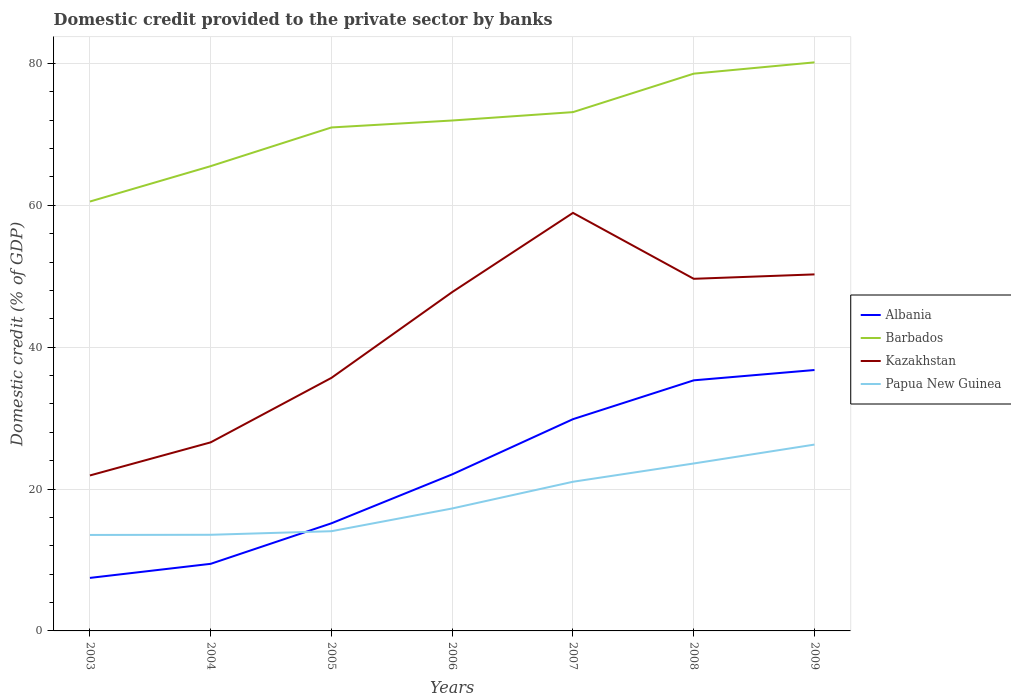Does the line corresponding to Kazakhstan intersect with the line corresponding to Albania?
Give a very brief answer. No. Is the number of lines equal to the number of legend labels?
Keep it short and to the point. Yes. Across all years, what is the maximum domestic credit provided to the private sector by banks in Kazakhstan?
Your answer should be compact. 21.92. What is the total domestic credit provided to the private sector by banks in Barbados in the graph?
Provide a succinct answer. -1.18. What is the difference between the highest and the second highest domestic credit provided to the private sector by banks in Albania?
Provide a succinct answer. 29.31. What is the difference between the highest and the lowest domestic credit provided to the private sector by banks in Barbados?
Offer a very short reply. 4. What is the difference between two consecutive major ticks on the Y-axis?
Give a very brief answer. 20. Are the values on the major ticks of Y-axis written in scientific E-notation?
Make the answer very short. No. Does the graph contain grids?
Your answer should be very brief. Yes. Where does the legend appear in the graph?
Your answer should be very brief. Center right. How many legend labels are there?
Your answer should be compact. 4. How are the legend labels stacked?
Give a very brief answer. Vertical. What is the title of the graph?
Your answer should be compact. Domestic credit provided to the private sector by banks. Does "Sao Tome and Principe" appear as one of the legend labels in the graph?
Your answer should be very brief. No. What is the label or title of the Y-axis?
Give a very brief answer. Domestic credit (% of GDP). What is the Domestic credit (% of GDP) of Albania in 2003?
Provide a short and direct response. 7.48. What is the Domestic credit (% of GDP) in Barbados in 2003?
Make the answer very short. 60.54. What is the Domestic credit (% of GDP) of Kazakhstan in 2003?
Offer a very short reply. 21.92. What is the Domestic credit (% of GDP) in Papua New Guinea in 2003?
Keep it short and to the point. 13.53. What is the Domestic credit (% of GDP) in Albania in 2004?
Make the answer very short. 9.46. What is the Domestic credit (% of GDP) in Barbados in 2004?
Ensure brevity in your answer.  65.53. What is the Domestic credit (% of GDP) in Kazakhstan in 2004?
Offer a terse response. 26.59. What is the Domestic credit (% of GDP) in Papua New Guinea in 2004?
Keep it short and to the point. 13.56. What is the Domestic credit (% of GDP) in Albania in 2005?
Provide a short and direct response. 15.18. What is the Domestic credit (% of GDP) in Barbados in 2005?
Offer a very short reply. 70.98. What is the Domestic credit (% of GDP) of Kazakhstan in 2005?
Offer a terse response. 35.68. What is the Domestic credit (% of GDP) in Papua New Guinea in 2005?
Provide a short and direct response. 14.06. What is the Domestic credit (% of GDP) in Albania in 2006?
Your response must be concise. 22.07. What is the Domestic credit (% of GDP) in Barbados in 2006?
Offer a terse response. 71.96. What is the Domestic credit (% of GDP) in Kazakhstan in 2006?
Provide a short and direct response. 47.77. What is the Domestic credit (% of GDP) in Papua New Guinea in 2006?
Give a very brief answer. 17.27. What is the Domestic credit (% of GDP) in Albania in 2007?
Offer a very short reply. 29.86. What is the Domestic credit (% of GDP) of Barbados in 2007?
Keep it short and to the point. 73.15. What is the Domestic credit (% of GDP) in Kazakhstan in 2007?
Ensure brevity in your answer.  58.94. What is the Domestic credit (% of GDP) in Papua New Guinea in 2007?
Ensure brevity in your answer.  21.03. What is the Domestic credit (% of GDP) in Albania in 2008?
Give a very brief answer. 35.33. What is the Domestic credit (% of GDP) of Barbados in 2008?
Offer a terse response. 78.57. What is the Domestic credit (% of GDP) of Kazakhstan in 2008?
Your answer should be compact. 49.64. What is the Domestic credit (% of GDP) of Papua New Guinea in 2008?
Your response must be concise. 23.61. What is the Domestic credit (% of GDP) in Albania in 2009?
Offer a very short reply. 36.78. What is the Domestic credit (% of GDP) in Barbados in 2009?
Your response must be concise. 80.16. What is the Domestic credit (% of GDP) in Kazakhstan in 2009?
Give a very brief answer. 50.27. What is the Domestic credit (% of GDP) of Papua New Guinea in 2009?
Your response must be concise. 26.27. Across all years, what is the maximum Domestic credit (% of GDP) of Albania?
Offer a terse response. 36.78. Across all years, what is the maximum Domestic credit (% of GDP) in Barbados?
Provide a short and direct response. 80.16. Across all years, what is the maximum Domestic credit (% of GDP) of Kazakhstan?
Offer a terse response. 58.94. Across all years, what is the maximum Domestic credit (% of GDP) of Papua New Guinea?
Provide a succinct answer. 26.27. Across all years, what is the minimum Domestic credit (% of GDP) of Albania?
Make the answer very short. 7.48. Across all years, what is the minimum Domestic credit (% of GDP) of Barbados?
Ensure brevity in your answer.  60.54. Across all years, what is the minimum Domestic credit (% of GDP) in Kazakhstan?
Ensure brevity in your answer.  21.92. Across all years, what is the minimum Domestic credit (% of GDP) of Papua New Guinea?
Ensure brevity in your answer.  13.53. What is the total Domestic credit (% of GDP) in Albania in the graph?
Your response must be concise. 156.16. What is the total Domestic credit (% of GDP) of Barbados in the graph?
Keep it short and to the point. 500.89. What is the total Domestic credit (% of GDP) in Kazakhstan in the graph?
Your answer should be very brief. 290.81. What is the total Domestic credit (% of GDP) of Papua New Guinea in the graph?
Make the answer very short. 129.32. What is the difference between the Domestic credit (% of GDP) in Albania in 2003 and that in 2004?
Give a very brief answer. -1.99. What is the difference between the Domestic credit (% of GDP) in Barbados in 2003 and that in 2004?
Give a very brief answer. -4.99. What is the difference between the Domestic credit (% of GDP) of Kazakhstan in 2003 and that in 2004?
Your response must be concise. -4.67. What is the difference between the Domestic credit (% of GDP) in Papua New Guinea in 2003 and that in 2004?
Your response must be concise. -0.03. What is the difference between the Domestic credit (% of GDP) in Albania in 2003 and that in 2005?
Keep it short and to the point. -7.7. What is the difference between the Domestic credit (% of GDP) of Barbados in 2003 and that in 2005?
Make the answer very short. -10.44. What is the difference between the Domestic credit (% of GDP) in Kazakhstan in 2003 and that in 2005?
Your answer should be compact. -13.76. What is the difference between the Domestic credit (% of GDP) of Papua New Guinea in 2003 and that in 2005?
Provide a succinct answer. -0.53. What is the difference between the Domestic credit (% of GDP) of Albania in 2003 and that in 2006?
Your answer should be compact. -14.6. What is the difference between the Domestic credit (% of GDP) of Barbados in 2003 and that in 2006?
Offer a terse response. -11.42. What is the difference between the Domestic credit (% of GDP) in Kazakhstan in 2003 and that in 2006?
Your answer should be compact. -25.85. What is the difference between the Domestic credit (% of GDP) of Papua New Guinea in 2003 and that in 2006?
Keep it short and to the point. -3.74. What is the difference between the Domestic credit (% of GDP) in Albania in 2003 and that in 2007?
Provide a succinct answer. -22.38. What is the difference between the Domestic credit (% of GDP) in Barbados in 2003 and that in 2007?
Offer a very short reply. -12.61. What is the difference between the Domestic credit (% of GDP) of Kazakhstan in 2003 and that in 2007?
Keep it short and to the point. -37.02. What is the difference between the Domestic credit (% of GDP) of Papua New Guinea in 2003 and that in 2007?
Provide a succinct answer. -7.5. What is the difference between the Domestic credit (% of GDP) of Albania in 2003 and that in 2008?
Your answer should be very brief. -27.86. What is the difference between the Domestic credit (% of GDP) in Barbados in 2003 and that in 2008?
Your answer should be very brief. -18.03. What is the difference between the Domestic credit (% of GDP) in Kazakhstan in 2003 and that in 2008?
Offer a very short reply. -27.73. What is the difference between the Domestic credit (% of GDP) of Papua New Guinea in 2003 and that in 2008?
Offer a very short reply. -10.08. What is the difference between the Domestic credit (% of GDP) of Albania in 2003 and that in 2009?
Your answer should be compact. -29.31. What is the difference between the Domestic credit (% of GDP) of Barbados in 2003 and that in 2009?
Provide a short and direct response. -19.62. What is the difference between the Domestic credit (% of GDP) in Kazakhstan in 2003 and that in 2009?
Give a very brief answer. -28.35. What is the difference between the Domestic credit (% of GDP) of Papua New Guinea in 2003 and that in 2009?
Provide a succinct answer. -12.74. What is the difference between the Domestic credit (% of GDP) in Albania in 2004 and that in 2005?
Give a very brief answer. -5.71. What is the difference between the Domestic credit (% of GDP) of Barbados in 2004 and that in 2005?
Your answer should be compact. -5.46. What is the difference between the Domestic credit (% of GDP) of Kazakhstan in 2004 and that in 2005?
Provide a succinct answer. -9.09. What is the difference between the Domestic credit (% of GDP) of Papua New Guinea in 2004 and that in 2005?
Your answer should be very brief. -0.5. What is the difference between the Domestic credit (% of GDP) in Albania in 2004 and that in 2006?
Your response must be concise. -12.61. What is the difference between the Domestic credit (% of GDP) of Barbados in 2004 and that in 2006?
Your answer should be compact. -6.44. What is the difference between the Domestic credit (% of GDP) in Kazakhstan in 2004 and that in 2006?
Make the answer very short. -21.19. What is the difference between the Domestic credit (% of GDP) of Papua New Guinea in 2004 and that in 2006?
Your answer should be compact. -3.71. What is the difference between the Domestic credit (% of GDP) of Albania in 2004 and that in 2007?
Offer a terse response. -20.39. What is the difference between the Domestic credit (% of GDP) of Barbados in 2004 and that in 2007?
Give a very brief answer. -7.62. What is the difference between the Domestic credit (% of GDP) in Kazakhstan in 2004 and that in 2007?
Your answer should be compact. -32.35. What is the difference between the Domestic credit (% of GDP) in Papua New Guinea in 2004 and that in 2007?
Your answer should be very brief. -7.48. What is the difference between the Domestic credit (% of GDP) in Albania in 2004 and that in 2008?
Give a very brief answer. -25.87. What is the difference between the Domestic credit (% of GDP) in Barbados in 2004 and that in 2008?
Your answer should be compact. -13.04. What is the difference between the Domestic credit (% of GDP) in Kazakhstan in 2004 and that in 2008?
Keep it short and to the point. -23.06. What is the difference between the Domestic credit (% of GDP) in Papua New Guinea in 2004 and that in 2008?
Your answer should be compact. -10.05. What is the difference between the Domestic credit (% of GDP) in Albania in 2004 and that in 2009?
Give a very brief answer. -27.32. What is the difference between the Domestic credit (% of GDP) of Barbados in 2004 and that in 2009?
Offer a very short reply. -14.63. What is the difference between the Domestic credit (% of GDP) in Kazakhstan in 2004 and that in 2009?
Offer a terse response. -23.68. What is the difference between the Domestic credit (% of GDP) of Papua New Guinea in 2004 and that in 2009?
Your answer should be compact. -12.72. What is the difference between the Domestic credit (% of GDP) in Albania in 2005 and that in 2006?
Your answer should be very brief. -6.9. What is the difference between the Domestic credit (% of GDP) of Barbados in 2005 and that in 2006?
Your response must be concise. -0.98. What is the difference between the Domestic credit (% of GDP) of Kazakhstan in 2005 and that in 2006?
Give a very brief answer. -12.09. What is the difference between the Domestic credit (% of GDP) of Papua New Guinea in 2005 and that in 2006?
Make the answer very short. -3.21. What is the difference between the Domestic credit (% of GDP) of Albania in 2005 and that in 2007?
Your answer should be very brief. -14.68. What is the difference between the Domestic credit (% of GDP) in Barbados in 2005 and that in 2007?
Your answer should be very brief. -2.16. What is the difference between the Domestic credit (% of GDP) of Kazakhstan in 2005 and that in 2007?
Provide a succinct answer. -23.26. What is the difference between the Domestic credit (% of GDP) in Papua New Guinea in 2005 and that in 2007?
Your answer should be compact. -6.97. What is the difference between the Domestic credit (% of GDP) of Albania in 2005 and that in 2008?
Provide a succinct answer. -20.16. What is the difference between the Domestic credit (% of GDP) of Barbados in 2005 and that in 2008?
Offer a terse response. -7.58. What is the difference between the Domestic credit (% of GDP) of Kazakhstan in 2005 and that in 2008?
Your answer should be very brief. -13.97. What is the difference between the Domestic credit (% of GDP) of Papua New Guinea in 2005 and that in 2008?
Your response must be concise. -9.55. What is the difference between the Domestic credit (% of GDP) of Albania in 2005 and that in 2009?
Make the answer very short. -21.61. What is the difference between the Domestic credit (% of GDP) of Barbados in 2005 and that in 2009?
Provide a short and direct response. -9.18. What is the difference between the Domestic credit (% of GDP) in Kazakhstan in 2005 and that in 2009?
Your response must be concise. -14.59. What is the difference between the Domestic credit (% of GDP) of Papua New Guinea in 2005 and that in 2009?
Ensure brevity in your answer.  -12.21. What is the difference between the Domestic credit (% of GDP) of Albania in 2006 and that in 2007?
Keep it short and to the point. -7.78. What is the difference between the Domestic credit (% of GDP) in Barbados in 2006 and that in 2007?
Your answer should be very brief. -1.18. What is the difference between the Domestic credit (% of GDP) in Kazakhstan in 2006 and that in 2007?
Provide a short and direct response. -11.16. What is the difference between the Domestic credit (% of GDP) in Papua New Guinea in 2006 and that in 2007?
Keep it short and to the point. -3.77. What is the difference between the Domestic credit (% of GDP) in Albania in 2006 and that in 2008?
Provide a short and direct response. -13.26. What is the difference between the Domestic credit (% of GDP) of Barbados in 2006 and that in 2008?
Give a very brief answer. -6.6. What is the difference between the Domestic credit (% of GDP) in Kazakhstan in 2006 and that in 2008?
Offer a very short reply. -1.87. What is the difference between the Domestic credit (% of GDP) in Papua New Guinea in 2006 and that in 2008?
Your answer should be very brief. -6.34. What is the difference between the Domestic credit (% of GDP) of Albania in 2006 and that in 2009?
Offer a terse response. -14.71. What is the difference between the Domestic credit (% of GDP) in Barbados in 2006 and that in 2009?
Your answer should be very brief. -8.2. What is the difference between the Domestic credit (% of GDP) of Kazakhstan in 2006 and that in 2009?
Offer a very short reply. -2.49. What is the difference between the Domestic credit (% of GDP) of Papua New Guinea in 2006 and that in 2009?
Give a very brief answer. -9.01. What is the difference between the Domestic credit (% of GDP) of Albania in 2007 and that in 2008?
Your answer should be very brief. -5.48. What is the difference between the Domestic credit (% of GDP) in Barbados in 2007 and that in 2008?
Your answer should be compact. -5.42. What is the difference between the Domestic credit (% of GDP) of Kazakhstan in 2007 and that in 2008?
Make the answer very short. 9.29. What is the difference between the Domestic credit (% of GDP) in Papua New Guinea in 2007 and that in 2008?
Keep it short and to the point. -2.58. What is the difference between the Domestic credit (% of GDP) of Albania in 2007 and that in 2009?
Give a very brief answer. -6.93. What is the difference between the Domestic credit (% of GDP) of Barbados in 2007 and that in 2009?
Make the answer very short. -7.02. What is the difference between the Domestic credit (% of GDP) of Kazakhstan in 2007 and that in 2009?
Give a very brief answer. 8.67. What is the difference between the Domestic credit (% of GDP) in Papua New Guinea in 2007 and that in 2009?
Keep it short and to the point. -5.24. What is the difference between the Domestic credit (% of GDP) in Albania in 2008 and that in 2009?
Your answer should be very brief. -1.45. What is the difference between the Domestic credit (% of GDP) of Barbados in 2008 and that in 2009?
Your answer should be very brief. -1.59. What is the difference between the Domestic credit (% of GDP) of Kazakhstan in 2008 and that in 2009?
Make the answer very short. -0.62. What is the difference between the Domestic credit (% of GDP) in Papua New Guinea in 2008 and that in 2009?
Your response must be concise. -2.66. What is the difference between the Domestic credit (% of GDP) in Albania in 2003 and the Domestic credit (% of GDP) in Barbados in 2004?
Offer a terse response. -58.05. What is the difference between the Domestic credit (% of GDP) of Albania in 2003 and the Domestic credit (% of GDP) of Kazakhstan in 2004?
Offer a terse response. -19.11. What is the difference between the Domestic credit (% of GDP) in Albania in 2003 and the Domestic credit (% of GDP) in Papua New Guinea in 2004?
Your answer should be very brief. -6.08. What is the difference between the Domestic credit (% of GDP) in Barbados in 2003 and the Domestic credit (% of GDP) in Kazakhstan in 2004?
Make the answer very short. 33.95. What is the difference between the Domestic credit (% of GDP) in Barbados in 2003 and the Domestic credit (% of GDP) in Papua New Guinea in 2004?
Ensure brevity in your answer.  46.98. What is the difference between the Domestic credit (% of GDP) of Kazakhstan in 2003 and the Domestic credit (% of GDP) of Papua New Guinea in 2004?
Your answer should be very brief. 8.36. What is the difference between the Domestic credit (% of GDP) in Albania in 2003 and the Domestic credit (% of GDP) in Barbados in 2005?
Your answer should be very brief. -63.51. What is the difference between the Domestic credit (% of GDP) in Albania in 2003 and the Domestic credit (% of GDP) in Kazakhstan in 2005?
Give a very brief answer. -28.2. What is the difference between the Domestic credit (% of GDP) in Albania in 2003 and the Domestic credit (% of GDP) in Papua New Guinea in 2005?
Ensure brevity in your answer.  -6.58. What is the difference between the Domestic credit (% of GDP) of Barbados in 2003 and the Domestic credit (% of GDP) of Kazakhstan in 2005?
Your answer should be very brief. 24.86. What is the difference between the Domestic credit (% of GDP) of Barbados in 2003 and the Domestic credit (% of GDP) of Papua New Guinea in 2005?
Provide a short and direct response. 46.48. What is the difference between the Domestic credit (% of GDP) of Kazakhstan in 2003 and the Domestic credit (% of GDP) of Papua New Guinea in 2005?
Keep it short and to the point. 7.86. What is the difference between the Domestic credit (% of GDP) of Albania in 2003 and the Domestic credit (% of GDP) of Barbados in 2006?
Give a very brief answer. -64.49. What is the difference between the Domestic credit (% of GDP) in Albania in 2003 and the Domestic credit (% of GDP) in Kazakhstan in 2006?
Keep it short and to the point. -40.3. What is the difference between the Domestic credit (% of GDP) of Albania in 2003 and the Domestic credit (% of GDP) of Papua New Guinea in 2006?
Your answer should be compact. -9.79. What is the difference between the Domestic credit (% of GDP) of Barbados in 2003 and the Domestic credit (% of GDP) of Kazakhstan in 2006?
Offer a terse response. 12.77. What is the difference between the Domestic credit (% of GDP) in Barbados in 2003 and the Domestic credit (% of GDP) in Papua New Guinea in 2006?
Offer a very short reply. 43.27. What is the difference between the Domestic credit (% of GDP) in Kazakhstan in 2003 and the Domestic credit (% of GDP) in Papua New Guinea in 2006?
Give a very brief answer. 4.65. What is the difference between the Domestic credit (% of GDP) of Albania in 2003 and the Domestic credit (% of GDP) of Barbados in 2007?
Give a very brief answer. -65.67. What is the difference between the Domestic credit (% of GDP) in Albania in 2003 and the Domestic credit (% of GDP) in Kazakhstan in 2007?
Offer a terse response. -51.46. What is the difference between the Domestic credit (% of GDP) in Albania in 2003 and the Domestic credit (% of GDP) in Papua New Guinea in 2007?
Make the answer very short. -13.56. What is the difference between the Domestic credit (% of GDP) of Barbados in 2003 and the Domestic credit (% of GDP) of Kazakhstan in 2007?
Provide a succinct answer. 1.6. What is the difference between the Domestic credit (% of GDP) in Barbados in 2003 and the Domestic credit (% of GDP) in Papua New Guinea in 2007?
Offer a terse response. 39.51. What is the difference between the Domestic credit (% of GDP) in Kazakhstan in 2003 and the Domestic credit (% of GDP) in Papua New Guinea in 2007?
Your response must be concise. 0.89. What is the difference between the Domestic credit (% of GDP) in Albania in 2003 and the Domestic credit (% of GDP) in Barbados in 2008?
Your answer should be very brief. -71.09. What is the difference between the Domestic credit (% of GDP) of Albania in 2003 and the Domestic credit (% of GDP) of Kazakhstan in 2008?
Provide a short and direct response. -42.17. What is the difference between the Domestic credit (% of GDP) of Albania in 2003 and the Domestic credit (% of GDP) of Papua New Guinea in 2008?
Make the answer very short. -16.13. What is the difference between the Domestic credit (% of GDP) of Barbados in 2003 and the Domestic credit (% of GDP) of Kazakhstan in 2008?
Make the answer very short. 10.89. What is the difference between the Domestic credit (% of GDP) of Barbados in 2003 and the Domestic credit (% of GDP) of Papua New Guinea in 2008?
Offer a very short reply. 36.93. What is the difference between the Domestic credit (% of GDP) in Kazakhstan in 2003 and the Domestic credit (% of GDP) in Papua New Guinea in 2008?
Provide a succinct answer. -1.69. What is the difference between the Domestic credit (% of GDP) in Albania in 2003 and the Domestic credit (% of GDP) in Barbados in 2009?
Ensure brevity in your answer.  -72.69. What is the difference between the Domestic credit (% of GDP) of Albania in 2003 and the Domestic credit (% of GDP) of Kazakhstan in 2009?
Offer a terse response. -42.79. What is the difference between the Domestic credit (% of GDP) in Albania in 2003 and the Domestic credit (% of GDP) in Papua New Guinea in 2009?
Make the answer very short. -18.8. What is the difference between the Domestic credit (% of GDP) in Barbados in 2003 and the Domestic credit (% of GDP) in Kazakhstan in 2009?
Ensure brevity in your answer.  10.27. What is the difference between the Domestic credit (% of GDP) of Barbados in 2003 and the Domestic credit (% of GDP) of Papua New Guinea in 2009?
Your answer should be very brief. 34.27. What is the difference between the Domestic credit (% of GDP) in Kazakhstan in 2003 and the Domestic credit (% of GDP) in Papua New Guinea in 2009?
Provide a short and direct response. -4.35. What is the difference between the Domestic credit (% of GDP) of Albania in 2004 and the Domestic credit (% of GDP) of Barbados in 2005?
Your response must be concise. -61.52. What is the difference between the Domestic credit (% of GDP) of Albania in 2004 and the Domestic credit (% of GDP) of Kazakhstan in 2005?
Your answer should be very brief. -26.22. What is the difference between the Domestic credit (% of GDP) in Albania in 2004 and the Domestic credit (% of GDP) in Papua New Guinea in 2005?
Offer a very short reply. -4.6. What is the difference between the Domestic credit (% of GDP) of Barbados in 2004 and the Domestic credit (% of GDP) of Kazakhstan in 2005?
Offer a terse response. 29.85. What is the difference between the Domestic credit (% of GDP) of Barbados in 2004 and the Domestic credit (% of GDP) of Papua New Guinea in 2005?
Offer a very short reply. 51.47. What is the difference between the Domestic credit (% of GDP) of Kazakhstan in 2004 and the Domestic credit (% of GDP) of Papua New Guinea in 2005?
Your answer should be very brief. 12.53. What is the difference between the Domestic credit (% of GDP) of Albania in 2004 and the Domestic credit (% of GDP) of Barbados in 2006?
Make the answer very short. -62.5. What is the difference between the Domestic credit (% of GDP) in Albania in 2004 and the Domestic credit (% of GDP) in Kazakhstan in 2006?
Make the answer very short. -38.31. What is the difference between the Domestic credit (% of GDP) of Albania in 2004 and the Domestic credit (% of GDP) of Papua New Guinea in 2006?
Keep it short and to the point. -7.8. What is the difference between the Domestic credit (% of GDP) in Barbados in 2004 and the Domestic credit (% of GDP) in Kazakhstan in 2006?
Ensure brevity in your answer.  17.75. What is the difference between the Domestic credit (% of GDP) in Barbados in 2004 and the Domestic credit (% of GDP) in Papua New Guinea in 2006?
Your response must be concise. 48.26. What is the difference between the Domestic credit (% of GDP) in Kazakhstan in 2004 and the Domestic credit (% of GDP) in Papua New Guinea in 2006?
Your response must be concise. 9.32. What is the difference between the Domestic credit (% of GDP) in Albania in 2004 and the Domestic credit (% of GDP) in Barbados in 2007?
Keep it short and to the point. -63.68. What is the difference between the Domestic credit (% of GDP) in Albania in 2004 and the Domestic credit (% of GDP) in Kazakhstan in 2007?
Offer a terse response. -49.48. What is the difference between the Domestic credit (% of GDP) of Albania in 2004 and the Domestic credit (% of GDP) of Papua New Guinea in 2007?
Provide a succinct answer. -11.57. What is the difference between the Domestic credit (% of GDP) of Barbados in 2004 and the Domestic credit (% of GDP) of Kazakhstan in 2007?
Your response must be concise. 6.59. What is the difference between the Domestic credit (% of GDP) of Barbados in 2004 and the Domestic credit (% of GDP) of Papua New Guinea in 2007?
Your answer should be compact. 44.5. What is the difference between the Domestic credit (% of GDP) in Kazakhstan in 2004 and the Domestic credit (% of GDP) in Papua New Guinea in 2007?
Offer a very short reply. 5.56. What is the difference between the Domestic credit (% of GDP) of Albania in 2004 and the Domestic credit (% of GDP) of Barbados in 2008?
Offer a very short reply. -69.11. What is the difference between the Domestic credit (% of GDP) of Albania in 2004 and the Domestic credit (% of GDP) of Kazakhstan in 2008?
Ensure brevity in your answer.  -40.18. What is the difference between the Domestic credit (% of GDP) in Albania in 2004 and the Domestic credit (% of GDP) in Papua New Guinea in 2008?
Provide a short and direct response. -14.15. What is the difference between the Domestic credit (% of GDP) of Barbados in 2004 and the Domestic credit (% of GDP) of Kazakhstan in 2008?
Your answer should be very brief. 15.88. What is the difference between the Domestic credit (% of GDP) of Barbados in 2004 and the Domestic credit (% of GDP) of Papua New Guinea in 2008?
Keep it short and to the point. 41.92. What is the difference between the Domestic credit (% of GDP) in Kazakhstan in 2004 and the Domestic credit (% of GDP) in Papua New Guinea in 2008?
Make the answer very short. 2.98. What is the difference between the Domestic credit (% of GDP) in Albania in 2004 and the Domestic credit (% of GDP) in Barbados in 2009?
Offer a very short reply. -70.7. What is the difference between the Domestic credit (% of GDP) in Albania in 2004 and the Domestic credit (% of GDP) in Kazakhstan in 2009?
Your answer should be very brief. -40.81. What is the difference between the Domestic credit (% of GDP) in Albania in 2004 and the Domestic credit (% of GDP) in Papua New Guinea in 2009?
Give a very brief answer. -16.81. What is the difference between the Domestic credit (% of GDP) in Barbados in 2004 and the Domestic credit (% of GDP) in Kazakhstan in 2009?
Keep it short and to the point. 15.26. What is the difference between the Domestic credit (% of GDP) of Barbados in 2004 and the Domestic credit (% of GDP) of Papua New Guinea in 2009?
Provide a succinct answer. 39.26. What is the difference between the Domestic credit (% of GDP) in Kazakhstan in 2004 and the Domestic credit (% of GDP) in Papua New Guinea in 2009?
Your answer should be very brief. 0.32. What is the difference between the Domestic credit (% of GDP) in Albania in 2005 and the Domestic credit (% of GDP) in Barbados in 2006?
Make the answer very short. -56.79. What is the difference between the Domestic credit (% of GDP) in Albania in 2005 and the Domestic credit (% of GDP) in Kazakhstan in 2006?
Offer a terse response. -32.6. What is the difference between the Domestic credit (% of GDP) of Albania in 2005 and the Domestic credit (% of GDP) of Papua New Guinea in 2006?
Make the answer very short. -2.09. What is the difference between the Domestic credit (% of GDP) in Barbados in 2005 and the Domestic credit (% of GDP) in Kazakhstan in 2006?
Give a very brief answer. 23.21. What is the difference between the Domestic credit (% of GDP) of Barbados in 2005 and the Domestic credit (% of GDP) of Papua New Guinea in 2006?
Your answer should be very brief. 53.72. What is the difference between the Domestic credit (% of GDP) of Kazakhstan in 2005 and the Domestic credit (% of GDP) of Papua New Guinea in 2006?
Provide a succinct answer. 18.41. What is the difference between the Domestic credit (% of GDP) of Albania in 2005 and the Domestic credit (% of GDP) of Barbados in 2007?
Offer a terse response. -57.97. What is the difference between the Domestic credit (% of GDP) of Albania in 2005 and the Domestic credit (% of GDP) of Kazakhstan in 2007?
Keep it short and to the point. -43.76. What is the difference between the Domestic credit (% of GDP) in Albania in 2005 and the Domestic credit (% of GDP) in Papua New Guinea in 2007?
Ensure brevity in your answer.  -5.86. What is the difference between the Domestic credit (% of GDP) in Barbados in 2005 and the Domestic credit (% of GDP) in Kazakhstan in 2007?
Offer a terse response. 12.05. What is the difference between the Domestic credit (% of GDP) of Barbados in 2005 and the Domestic credit (% of GDP) of Papua New Guinea in 2007?
Provide a short and direct response. 49.95. What is the difference between the Domestic credit (% of GDP) in Kazakhstan in 2005 and the Domestic credit (% of GDP) in Papua New Guinea in 2007?
Make the answer very short. 14.65. What is the difference between the Domestic credit (% of GDP) in Albania in 2005 and the Domestic credit (% of GDP) in Barbados in 2008?
Ensure brevity in your answer.  -63.39. What is the difference between the Domestic credit (% of GDP) of Albania in 2005 and the Domestic credit (% of GDP) of Kazakhstan in 2008?
Offer a terse response. -34.47. What is the difference between the Domestic credit (% of GDP) of Albania in 2005 and the Domestic credit (% of GDP) of Papua New Guinea in 2008?
Give a very brief answer. -8.43. What is the difference between the Domestic credit (% of GDP) in Barbados in 2005 and the Domestic credit (% of GDP) in Kazakhstan in 2008?
Provide a short and direct response. 21.34. What is the difference between the Domestic credit (% of GDP) of Barbados in 2005 and the Domestic credit (% of GDP) of Papua New Guinea in 2008?
Make the answer very short. 47.38. What is the difference between the Domestic credit (% of GDP) in Kazakhstan in 2005 and the Domestic credit (% of GDP) in Papua New Guinea in 2008?
Make the answer very short. 12.07. What is the difference between the Domestic credit (% of GDP) in Albania in 2005 and the Domestic credit (% of GDP) in Barbados in 2009?
Provide a succinct answer. -64.99. What is the difference between the Domestic credit (% of GDP) in Albania in 2005 and the Domestic credit (% of GDP) in Kazakhstan in 2009?
Give a very brief answer. -35.09. What is the difference between the Domestic credit (% of GDP) of Albania in 2005 and the Domestic credit (% of GDP) of Papua New Guinea in 2009?
Keep it short and to the point. -11.1. What is the difference between the Domestic credit (% of GDP) of Barbados in 2005 and the Domestic credit (% of GDP) of Kazakhstan in 2009?
Provide a short and direct response. 20.72. What is the difference between the Domestic credit (% of GDP) of Barbados in 2005 and the Domestic credit (% of GDP) of Papua New Guinea in 2009?
Make the answer very short. 44.71. What is the difference between the Domestic credit (% of GDP) of Kazakhstan in 2005 and the Domestic credit (% of GDP) of Papua New Guinea in 2009?
Provide a succinct answer. 9.41. What is the difference between the Domestic credit (% of GDP) in Albania in 2006 and the Domestic credit (% of GDP) in Barbados in 2007?
Your response must be concise. -51.07. What is the difference between the Domestic credit (% of GDP) in Albania in 2006 and the Domestic credit (% of GDP) in Kazakhstan in 2007?
Offer a very short reply. -36.86. What is the difference between the Domestic credit (% of GDP) of Albania in 2006 and the Domestic credit (% of GDP) of Papua New Guinea in 2007?
Provide a succinct answer. 1.04. What is the difference between the Domestic credit (% of GDP) in Barbados in 2006 and the Domestic credit (% of GDP) in Kazakhstan in 2007?
Offer a terse response. 13.02. What is the difference between the Domestic credit (% of GDP) of Barbados in 2006 and the Domestic credit (% of GDP) of Papua New Guinea in 2007?
Your answer should be compact. 50.93. What is the difference between the Domestic credit (% of GDP) of Kazakhstan in 2006 and the Domestic credit (% of GDP) of Papua New Guinea in 2007?
Offer a very short reply. 26.74. What is the difference between the Domestic credit (% of GDP) in Albania in 2006 and the Domestic credit (% of GDP) in Barbados in 2008?
Keep it short and to the point. -56.49. What is the difference between the Domestic credit (% of GDP) of Albania in 2006 and the Domestic credit (% of GDP) of Kazakhstan in 2008?
Give a very brief answer. -27.57. What is the difference between the Domestic credit (% of GDP) of Albania in 2006 and the Domestic credit (% of GDP) of Papua New Guinea in 2008?
Make the answer very short. -1.53. What is the difference between the Domestic credit (% of GDP) of Barbados in 2006 and the Domestic credit (% of GDP) of Kazakhstan in 2008?
Provide a short and direct response. 22.32. What is the difference between the Domestic credit (% of GDP) of Barbados in 2006 and the Domestic credit (% of GDP) of Papua New Guinea in 2008?
Provide a succinct answer. 48.36. What is the difference between the Domestic credit (% of GDP) in Kazakhstan in 2006 and the Domestic credit (% of GDP) in Papua New Guinea in 2008?
Your response must be concise. 24.17. What is the difference between the Domestic credit (% of GDP) in Albania in 2006 and the Domestic credit (% of GDP) in Barbados in 2009?
Offer a terse response. -58.09. What is the difference between the Domestic credit (% of GDP) of Albania in 2006 and the Domestic credit (% of GDP) of Kazakhstan in 2009?
Keep it short and to the point. -28.19. What is the difference between the Domestic credit (% of GDP) of Albania in 2006 and the Domestic credit (% of GDP) of Papua New Guinea in 2009?
Provide a short and direct response. -4.2. What is the difference between the Domestic credit (% of GDP) of Barbados in 2006 and the Domestic credit (% of GDP) of Kazakhstan in 2009?
Provide a short and direct response. 21.7. What is the difference between the Domestic credit (% of GDP) in Barbados in 2006 and the Domestic credit (% of GDP) in Papua New Guinea in 2009?
Provide a short and direct response. 45.69. What is the difference between the Domestic credit (% of GDP) of Kazakhstan in 2006 and the Domestic credit (% of GDP) of Papua New Guinea in 2009?
Your answer should be compact. 21.5. What is the difference between the Domestic credit (% of GDP) in Albania in 2007 and the Domestic credit (% of GDP) in Barbados in 2008?
Provide a succinct answer. -48.71. What is the difference between the Domestic credit (% of GDP) in Albania in 2007 and the Domestic credit (% of GDP) in Kazakhstan in 2008?
Make the answer very short. -19.79. What is the difference between the Domestic credit (% of GDP) in Albania in 2007 and the Domestic credit (% of GDP) in Papua New Guinea in 2008?
Make the answer very short. 6.25. What is the difference between the Domestic credit (% of GDP) in Barbados in 2007 and the Domestic credit (% of GDP) in Kazakhstan in 2008?
Offer a very short reply. 23.5. What is the difference between the Domestic credit (% of GDP) of Barbados in 2007 and the Domestic credit (% of GDP) of Papua New Guinea in 2008?
Your answer should be very brief. 49.54. What is the difference between the Domestic credit (% of GDP) of Kazakhstan in 2007 and the Domestic credit (% of GDP) of Papua New Guinea in 2008?
Your answer should be compact. 35.33. What is the difference between the Domestic credit (% of GDP) in Albania in 2007 and the Domestic credit (% of GDP) in Barbados in 2009?
Offer a terse response. -50.31. What is the difference between the Domestic credit (% of GDP) in Albania in 2007 and the Domestic credit (% of GDP) in Kazakhstan in 2009?
Your answer should be very brief. -20.41. What is the difference between the Domestic credit (% of GDP) in Albania in 2007 and the Domestic credit (% of GDP) in Papua New Guinea in 2009?
Give a very brief answer. 3.58. What is the difference between the Domestic credit (% of GDP) in Barbados in 2007 and the Domestic credit (% of GDP) in Kazakhstan in 2009?
Provide a short and direct response. 22.88. What is the difference between the Domestic credit (% of GDP) of Barbados in 2007 and the Domestic credit (% of GDP) of Papua New Guinea in 2009?
Keep it short and to the point. 46.87. What is the difference between the Domestic credit (% of GDP) in Kazakhstan in 2007 and the Domestic credit (% of GDP) in Papua New Guinea in 2009?
Make the answer very short. 32.67. What is the difference between the Domestic credit (% of GDP) of Albania in 2008 and the Domestic credit (% of GDP) of Barbados in 2009?
Ensure brevity in your answer.  -44.83. What is the difference between the Domestic credit (% of GDP) of Albania in 2008 and the Domestic credit (% of GDP) of Kazakhstan in 2009?
Your answer should be very brief. -14.94. What is the difference between the Domestic credit (% of GDP) of Albania in 2008 and the Domestic credit (% of GDP) of Papua New Guinea in 2009?
Your answer should be very brief. 9.06. What is the difference between the Domestic credit (% of GDP) of Barbados in 2008 and the Domestic credit (% of GDP) of Kazakhstan in 2009?
Your response must be concise. 28.3. What is the difference between the Domestic credit (% of GDP) in Barbados in 2008 and the Domestic credit (% of GDP) in Papua New Guinea in 2009?
Give a very brief answer. 52.3. What is the difference between the Domestic credit (% of GDP) in Kazakhstan in 2008 and the Domestic credit (% of GDP) in Papua New Guinea in 2009?
Your response must be concise. 23.37. What is the average Domestic credit (% of GDP) in Albania per year?
Offer a very short reply. 22.31. What is the average Domestic credit (% of GDP) of Barbados per year?
Give a very brief answer. 71.56. What is the average Domestic credit (% of GDP) in Kazakhstan per year?
Provide a short and direct response. 41.54. What is the average Domestic credit (% of GDP) of Papua New Guinea per year?
Your response must be concise. 18.47. In the year 2003, what is the difference between the Domestic credit (% of GDP) in Albania and Domestic credit (% of GDP) in Barbados?
Keep it short and to the point. -53.06. In the year 2003, what is the difference between the Domestic credit (% of GDP) in Albania and Domestic credit (% of GDP) in Kazakhstan?
Make the answer very short. -14.44. In the year 2003, what is the difference between the Domestic credit (% of GDP) of Albania and Domestic credit (% of GDP) of Papua New Guinea?
Your answer should be compact. -6.05. In the year 2003, what is the difference between the Domestic credit (% of GDP) of Barbados and Domestic credit (% of GDP) of Kazakhstan?
Ensure brevity in your answer.  38.62. In the year 2003, what is the difference between the Domestic credit (% of GDP) in Barbados and Domestic credit (% of GDP) in Papua New Guinea?
Ensure brevity in your answer.  47.01. In the year 2003, what is the difference between the Domestic credit (% of GDP) in Kazakhstan and Domestic credit (% of GDP) in Papua New Guinea?
Give a very brief answer. 8.39. In the year 2004, what is the difference between the Domestic credit (% of GDP) of Albania and Domestic credit (% of GDP) of Barbados?
Provide a succinct answer. -56.07. In the year 2004, what is the difference between the Domestic credit (% of GDP) of Albania and Domestic credit (% of GDP) of Kazakhstan?
Offer a terse response. -17.13. In the year 2004, what is the difference between the Domestic credit (% of GDP) in Albania and Domestic credit (% of GDP) in Papua New Guinea?
Offer a very short reply. -4.09. In the year 2004, what is the difference between the Domestic credit (% of GDP) of Barbados and Domestic credit (% of GDP) of Kazakhstan?
Keep it short and to the point. 38.94. In the year 2004, what is the difference between the Domestic credit (% of GDP) in Barbados and Domestic credit (% of GDP) in Papua New Guinea?
Your answer should be compact. 51.97. In the year 2004, what is the difference between the Domestic credit (% of GDP) in Kazakhstan and Domestic credit (% of GDP) in Papua New Guinea?
Keep it short and to the point. 13.03. In the year 2005, what is the difference between the Domestic credit (% of GDP) of Albania and Domestic credit (% of GDP) of Barbados?
Your answer should be compact. -55.81. In the year 2005, what is the difference between the Domestic credit (% of GDP) in Albania and Domestic credit (% of GDP) in Kazakhstan?
Your response must be concise. -20.5. In the year 2005, what is the difference between the Domestic credit (% of GDP) of Albania and Domestic credit (% of GDP) of Papua New Guinea?
Give a very brief answer. 1.12. In the year 2005, what is the difference between the Domestic credit (% of GDP) in Barbados and Domestic credit (% of GDP) in Kazakhstan?
Your answer should be very brief. 35.3. In the year 2005, what is the difference between the Domestic credit (% of GDP) in Barbados and Domestic credit (% of GDP) in Papua New Guinea?
Your answer should be very brief. 56.92. In the year 2005, what is the difference between the Domestic credit (% of GDP) of Kazakhstan and Domestic credit (% of GDP) of Papua New Guinea?
Ensure brevity in your answer.  21.62. In the year 2006, what is the difference between the Domestic credit (% of GDP) in Albania and Domestic credit (% of GDP) in Barbados?
Give a very brief answer. -49.89. In the year 2006, what is the difference between the Domestic credit (% of GDP) of Albania and Domestic credit (% of GDP) of Kazakhstan?
Your response must be concise. -25.7. In the year 2006, what is the difference between the Domestic credit (% of GDP) in Albania and Domestic credit (% of GDP) in Papua New Guinea?
Provide a short and direct response. 4.81. In the year 2006, what is the difference between the Domestic credit (% of GDP) of Barbados and Domestic credit (% of GDP) of Kazakhstan?
Give a very brief answer. 24.19. In the year 2006, what is the difference between the Domestic credit (% of GDP) in Barbados and Domestic credit (% of GDP) in Papua New Guinea?
Provide a succinct answer. 54.7. In the year 2006, what is the difference between the Domestic credit (% of GDP) in Kazakhstan and Domestic credit (% of GDP) in Papua New Guinea?
Offer a terse response. 30.51. In the year 2007, what is the difference between the Domestic credit (% of GDP) in Albania and Domestic credit (% of GDP) in Barbados?
Offer a very short reply. -43.29. In the year 2007, what is the difference between the Domestic credit (% of GDP) of Albania and Domestic credit (% of GDP) of Kazakhstan?
Give a very brief answer. -29.08. In the year 2007, what is the difference between the Domestic credit (% of GDP) of Albania and Domestic credit (% of GDP) of Papua New Guinea?
Make the answer very short. 8.82. In the year 2007, what is the difference between the Domestic credit (% of GDP) in Barbados and Domestic credit (% of GDP) in Kazakhstan?
Your response must be concise. 14.21. In the year 2007, what is the difference between the Domestic credit (% of GDP) in Barbados and Domestic credit (% of GDP) in Papua New Guinea?
Keep it short and to the point. 52.11. In the year 2007, what is the difference between the Domestic credit (% of GDP) of Kazakhstan and Domestic credit (% of GDP) of Papua New Guinea?
Keep it short and to the point. 37.91. In the year 2008, what is the difference between the Domestic credit (% of GDP) in Albania and Domestic credit (% of GDP) in Barbados?
Make the answer very short. -43.24. In the year 2008, what is the difference between the Domestic credit (% of GDP) of Albania and Domestic credit (% of GDP) of Kazakhstan?
Offer a very short reply. -14.31. In the year 2008, what is the difference between the Domestic credit (% of GDP) of Albania and Domestic credit (% of GDP) of Papua New Guinea?
Offer a very short reply. 11.72. In the year 2008, what is the difference between the Domestic credit (% of GDP) of Barbados and Domestic credit (% of GDP) of Kazakhstan?
Keep it short and to the point. 28.92. In the year 2008, what is the difference between the Domestic credit (% of GDP) of Barbados and Domestic credit (% of GDP) of Papua New Guinea?
Keep it short and to the point. 54.96. In the year 2008, what is the difference between the Domestic credit (% of GDP) of Kazakhstan and Domestic credit (% of GDP) of Papua New Guinea?
Your answer should be very brief. 26.04. In the year 2009, what is the difference between the Domestic credit (% of GDP) in Albania and Domestic credit (% of GDP) in Barbados?
Offer a terse response. -43.38. In the year 2009, what is the difference between the Domestic credit (% of GDP) in Albania and Domestic credit (% of GDP) in Kazakhstan?
Offer a very short reply. -13.48. In the year 2009, what is the difference between the Domestic credit (% of GDP) of Albania and Domestic credit (% of GDP) of Papua New Guinea?
Offer a very short reply. 10.51. In the year 2009, what is the difference between the Domestic credit (% of GDP) of Barbados and Domestic credit (% of GDP) of Kazakhstan?
Ensure brevity in your answer.  29.9. In the year 2009, what is the difference between the Domestic credit (% of GDP) in Barbados and Domestic credit (% of GDP) in Papua New Guinea?
Make the answer very short. 53.89. In the year 2009, what is the difference between the Domestic credit (% of GDP) in Kazakhstan and Domestic credit (% of GDP) in Papua New Guinea?
Keep it short and to the point. 23.99. What is the ratio of the Domestic credit (% of GDP) of Albania in 2003 to that in 2004?
Make the answer very short. 0.79. What is the ratio of the Domestic credit (% of GDP) in Barbados in 2003 to that in 2004?
Ensure brevity in your answer.  0.92. What is the ratio of the Domestic credit (% of GDP) in Kazakhstan in 2003 to that in 2004?
Provide a short and direct response. 0.82. What is the ratio of the Domestic credit (% of GDP) in Albania in 2003 to that in 2005?
Your response must be concise. 0.49. What is the ratio of the Domestic credit (% of GDP) of Barbados in 2003 to that in 2005?
Make the answer very short. 0.85. What is the ratio of the Domestic credit (% of GDP) of Kazakhstan in 2003 to that in 2005?
Provide a short and direct response. 0.61. What is the ratio of the Domestic credit (% of GDP) in Papua New Guinea in 2003 to that in 2005?
Provide a succinct answer. 0.96. What is the ratio of the Domestic credit (% of GDP) of Albania in 2003 to that in 2006?
Offer a very short reply. 0.34. What is the ratio of the Domestic credit (% of GDP) in Barbados in 2003 to that in 2006?
Provide a succinct answer. 0.84. What is the ratio of the Domestic credit (% of GDP) in Kazakhstan in 2003 to that in 2006?
Your response must be concise. 0.46. What is the ratio of the Domestic credit (% of GDP) of Papua New Guinea in 2003 to that in 2006?
Offer a very short reply. 0.78. What is the ratio of the Domestic credit (% of GDP) in Albania in 2003 to that in 2007?
Offer a very short reply. 0.25. What is the ratio of the Domestic credit (% of GDP) of Barbados in 2003 to that in 2007?
Your answer should be compact. 0.83. What is the ratio of the Domestic credit (% of GDP) of Kazakhstan in 2003 to that in 2007?
Provide a succinct answer. 0.37. What is the ratio of the Domestic credit (% of GDP) of Papua New Guinea in 2003 to that in 2007?
Ensure brevity in your answer.  0.64. What is the ratio of the Domestic credit (% of GDP) of Albania in 2003 to that in 2008?
Offer a very short reply. 0.21. What is the ratio of the Domestic credit (% of GDP) of Barbados in 2003 to that in 2008?
Provide a succinct answer. 0.77. What is the ratio of the Domestic credit (% of GDP) of Kazakhstan in 2003 to that in 2008?
Provide a short and direct response. 0.44. What is the ratio of the Domestic credit (% of GDP) in Papua New Guinea in 2003 to that in 2008?
Offer a very short reply. 0.57. What is the ratio of the Domestic credit (% of GDP) of Albania in 2003 to that in 2009?
Your answer should be compact. 0.2. What is the ratio of the Domestic credit (% of GDP) in Barbados in 2003 to that in 2009?
Offer a very short reply. 0.76. What is the ratio of the Domestic credit (% of GDP) in Kazakhstan in 2003 to that in 2009?
Offer a terse response. 0.44. What is the ratio of the Domestic credit (% of GDP) of Papua New Guinea in 2003 to that in 2009?
Your answer should be compact. 0.52. What is the ratio of the Domestic credit (% of GDP) of Albania in 2004 to that in 2005?
Your answer should be very brief. 0.62. What is the ratio of the Domestic credit (% of GDP) of Kazakhstan in 2004 to that in 2005?
Your response must be concise. 0.75. What is the ratio of the Domestic credit (% of GDP) in Papua New Guinea in 2004 to that in 2005?
Provide a succinct answer. 0.96. What is the ratio of the Domestic credit (% of GDP) in Albania in 2004 to that in 2006?
Ensure brevity in your answer.  0.43. What is the ratio of the Domestic credit (% of GDP) of Barbados in 2004 to that in 2006?
Your answer should be very brief. 0.91. What is the ratio of the Domestic credit (% of GDP) of Kazakhstan in 2004 to that in 2006?
Give a very brief answer. 0.56. What is the ratio of the Domestic credit (% of GDP) in Papua New Guinea in 2004 to that in 2006?
Your answer should be very brief. 0.79. What is the ratio of the Domestic credit (% of GDP) in Albania in 2004 to that in 2007?
Offer a very short reply. 0.32. What is the ratio of the Domestic credit (% of GDP) of Barbados in 2004 to that in 2007?
Make the answer very short. 0.9. What is the ratio of the Domestic credit (% of GDP) in Kazakhstan in 2004 to that in 2007?
Your answer should be very brief. 0.45. What is the ratio of the Domestic credit (% of GDP) in Papua New Guinea in 2004 to that in 2007?
Make the answer very short. 0.64. What is the ratio of the Domestic credit (% of GDP) in Albania in 2004 to that in 2008?
Give a very brief answer. 0.27. What is the ratio of the Domestic credit (% of GDP) in Barbados in 2004 to that in 2008?
Your answer should be compact. 0.83. What is the ratio of the Domestic credit (% of GDP) of Kazakhstan in 2004 to that in 2008?
Your response must be concise. 0.54. What is the ratio of the Domestic credit (% of GDP) of Papua New Guinea in 2004 to that in 2008?
Ensure brevity in your answer.  0.57. What is the ratio of the Domestic credit (% of GDP) of Albania in 2004 to that in 2009?
Your answer should be compact. 0.26. What is the ratio of the Domestic credit (% of GDP) in Barbados in 2004 to that in 2009?
Your answer should be very brief. 0.82. What is the ratio of the Domestic credit (% of GDP) of Kazakhstan in 2004 to that in 2009?
Give a very brief answer. 0.53. What is the ratio of the Domestic credit (% of GDP) of Papua New Guinea in 2004 to that in 2009?
Your response must be concise. 0.52. What is the ratio of the Domestic credit (% of GDP) in Albania in 2005 to that in 2006?
Provide a succinct answer. 0.69. What is the ratio of the Domestic credit (% of GDP) in Barbados in 2005 to that in 2006?
Your response must be concise. 0.99. What is the ratio of the Domestic credit (% of GDP) of Kazakhstan in 2005 to that in 2006?
Provide a short and direct response. 0.75. What is the ratio of the Domestic credit (% of GDP) in Papua New Guinea in 2005 to that in 2006?
Ensure brevity in your answer.  0.81. What is the ratio of the Domestic credit (% of GDP) in Albania in 2005 to that in 2007?
Keep it short and to the point. 0.51. What is the ratio of the Domestic credit (% of GDP) of Barbados in 2005 to that in 2007?
Keep it short and to the point. 0.97. What is the ratio of the Domestic credit (% of GDP) of Kazakhstan in 2005 to that in 2007?
Give a very brief answer. 0.61. What is the ratio of the Domestic credit (% of GDP) of Papua New Guinea in 2005 to that in 2007?
Your answer should be compact. 0.67. What is the ratio of the Domestic credit (% of GDP) of Albania in 2005 to that in 2008?
Your answer should be compact. 0.43. What is the ratio of the Domestic credit (% of GDP) in Barbados in 2005 to that in 2008?
Offer a terse response. 0.9. What is the ratio of the Domestic credit (% of GDP) of Kazakhstan in 2005 to that in 2008?
Offer a very short reply. 0.72. What is the ratio of the Domestic credit (% of GDP) in Papua New Guinea in 2005 to that in 2008?
Provide a succinct answer. 0.6. What is the ratio of the Domestic credit (% of GDP) of Albania in 2005 to that in 2009?
Provide a succinct answer. 0.41. What is the ratio of the Domestic credit (% of GDP) of Barbados in 2005 to that in 2009?
Provide a short and direct response. 0.89. What is the ratio of the Domestic credit (% of GDP) in Kazakhstan in 2005 to that in 2009?
Offer a very short reply. 0.71. What is the ratio of the Domestic credit (% of GDP) in Papua New Guinea in 2005 to that in 2009?
Offer a very short reply. 0.54. What is the ratio of the Domestic credit (% of GDP) of Albania in 2006 to that in 2007?
Give a very brief answer. 0.74. What is the ratio of the Domestic credit (% of GDP) of Barbados in 2006 to that in 2007?
Offer a very short reply. 0.98. What is the ratio of the Domestic credit (% of GDP) in Kazakhstan in 2006 to that in 2007?
Your response must be concise. 0.81. What is the ratio of the Domestic credit (% of GDP) of Papua New Guinea in 2006 to that in 2007?
Your answer should be very brief. 0.82. What is the ratio of the Domestic credit (% of GDP) of Albania in 2006 to that in 2008?
Provide a short and direct response. 0.62. What is the ratio of the Domestic credit (% of GDP) of Barbados in 2006 to that in 2008?
Your answer should be very brief. 0.92. What is the ratio of the Domestic credit (% of GDP) in Kazakhstan in 2006 to that in 2008?
Provide a short and direct response. 0.96. What is the ratio of the Domestic credit (% of GDP) in Papua New Guinea in 2006 to that in 2008?
Your response must be concise. 0.73. What is the ratio of the Domestic credit (% of GDP) in Albania in 2006 to that in 2009?
Keep it short and to the point. 0.6. What is the ratio of the Domestic credit (% of GDP) in Barbados in 2006 to that in 2009?
Offer a very short reply. 0.9. What is the ratio of the Domestic credit (% of GDP) of Kazakhstan in 2006 to that in 2009?
Your response must be concise. 0.95. What is the ratio of the Domestic credit (% of GDP) of Papua New Guinea in 2006 to that in 2009?
Keep it short and to the point. 0.66. What is the ratio of the Domestic credit (% of GDP) in Albania in 2007 to that in 2008?
Give a very brief answer. 0.84. What is the ratio of the Domestic credit (% of GDP) in Kazakhstan in 2007 to that in 2008?
Provide a short and direct response. 1.19. What is the ratio of the Domestic credit (% of GDP) in Papua New Guinea in 2007 to that in 2008?
Give a very brief answer. 0.89. What is the ratio of the Domestic credit (% of GDP) in Albania in 2007 to that in 2009?
Your answer should be very brief. 0.81. What is the ratio of the Domestic credit (% of GDP) in Barbados in 2007 to that in 2009?
Your answer should be compact. 0.91. What is the ratio of the Domestic credit (% of GDP) in Kazakhstan in 2007 to that in 2009?
Your answer should be compact. 1.17. What is the ratio of the Domestic credit (% of GDP) of Papua New Guinea in 2007 to that in 2009?
Keep it short and to the point. 0.8. What is the ratio of the Domestic credit (% of GDP) in Albania in 2008 to that in 2009?
Offer a terse response. 0.96. What is the ratio of the Domestic credit (% of GDP) of Barbados in 2008 to that in 2009?
Your response must be concise. 0.98. What is the ratio of the Domestic credit (% of GDP) in Kazakhstan in 2008 to that in 2009?
Your response must be concise. 0.99. What is the ratio of the Domestic credit (% of GDP) of Papua New Guinea in 2008 to that in 2009?
Your answer should be very brief. 0.9. What is the difference between the highest and the second highest Domestic credit (% of GDP) of Albania?
Your answer should be very brief. 1.45. What is the difference between the highest and the second highest Domestic credit (% of GDP) in Barbados?
Keep it short and to the point. 1.59. What is the difference between the highest and the second highest Domestic credit (% of GDP) of Kazakhstan?
Provide a succinct answer. 8.67. What is the difference between the highest and the second highest Domestic credit (% of GDP) in Papua New Guinea?
Your answer should be compact. 2.66. What is the difference between the highest and the lowest Domestic credit (% of GDP) of Albania?
Your response must be concise. 29.31. What is the difference between the highest and the lowest Domestic credit (% of GDP) of Barbados?
Provide a succinct answer. 19.62. What is the difference between the highest and the lowest Domestic credit (% of GDP) in Kazakhstan?
Make the answer very short. 37.02. What is the difference between the highest and the lowest Domestic credit (% of GDP) of Papua New Guinea?
Keep it short and to the point. 12.74. 